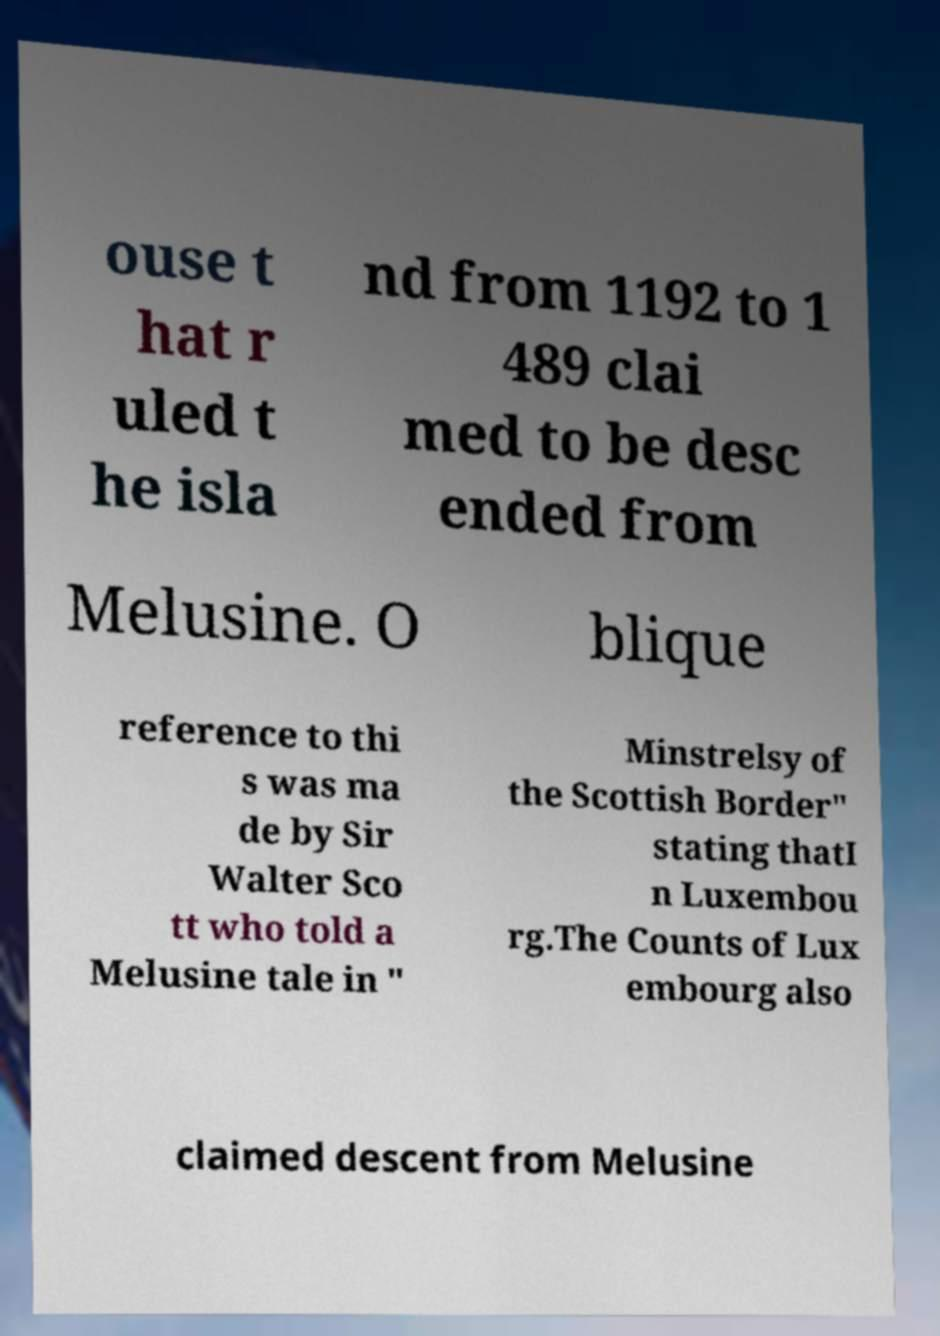Please identify and transcribe the text found in this image. ouse t hat r uled t he isla nd from 1192 to 1 489 clai med to be desc ended from Melusine. O blique reference to thi s was ma de by Sir Walter Sco tt who told a Melusine tale in " Minstrelsy of the Scottish Border" stating thatI n Luxembou rg.The Counts of Lux embourg also claimed descent from Melusine 